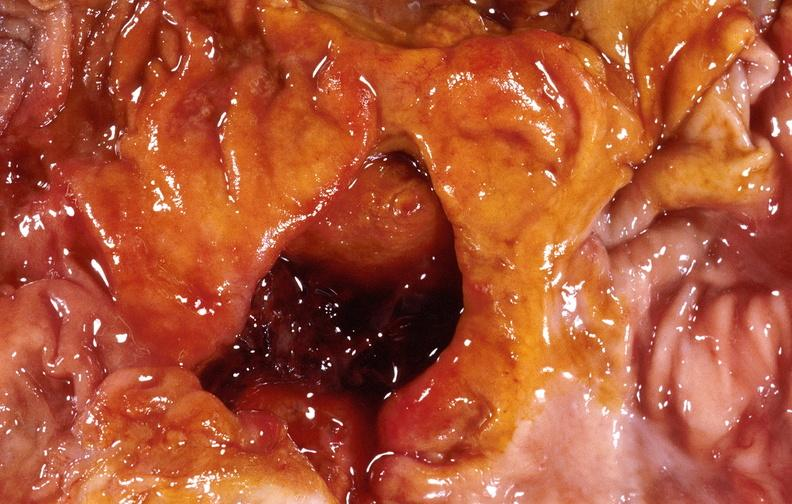what is present?
Answer the question using a single word or phrase. Gastrointestinal 